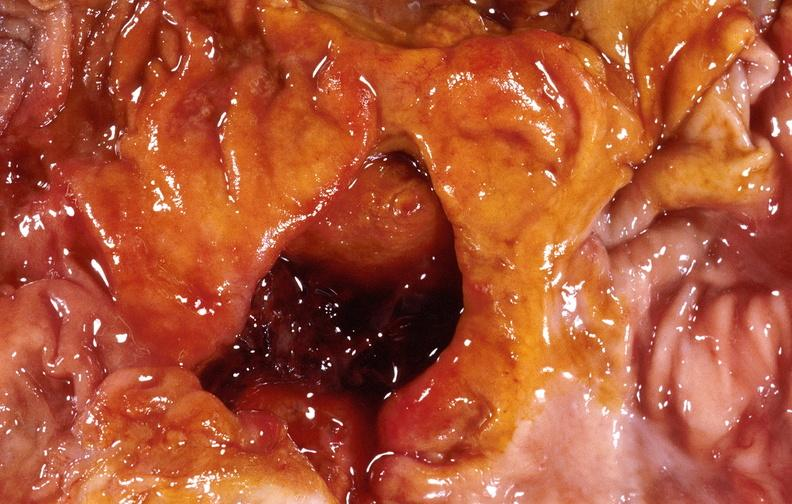what is present?
Answer the question using a single word or phrase. Gastrointestinal 